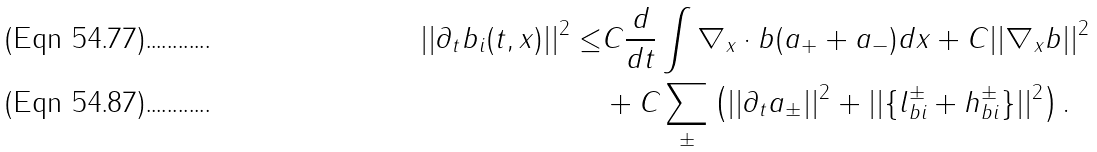<formula> <loc_0><loc_0><loc_500><loc_500>| | \partial _ { t } b _ { i } ( t , x ) | | ^ { 2 } \leq & C \frac { d } { d t } \int \nabla _ { x } \cdot b ( a _ { + } + a _ { - } ) d x + C | | \nabla _ { x } b | | ^ { 2 } \\ & + C \sum _ { \pm } \left ( | | \partial _ { t } a _ { \pm } | | ^ { 2 } + | | \{ l _ { b i } ^ { \pm } + h _ { b i } ^ { \pm } \} | | ^ { 2 } \right ) .</formula> 